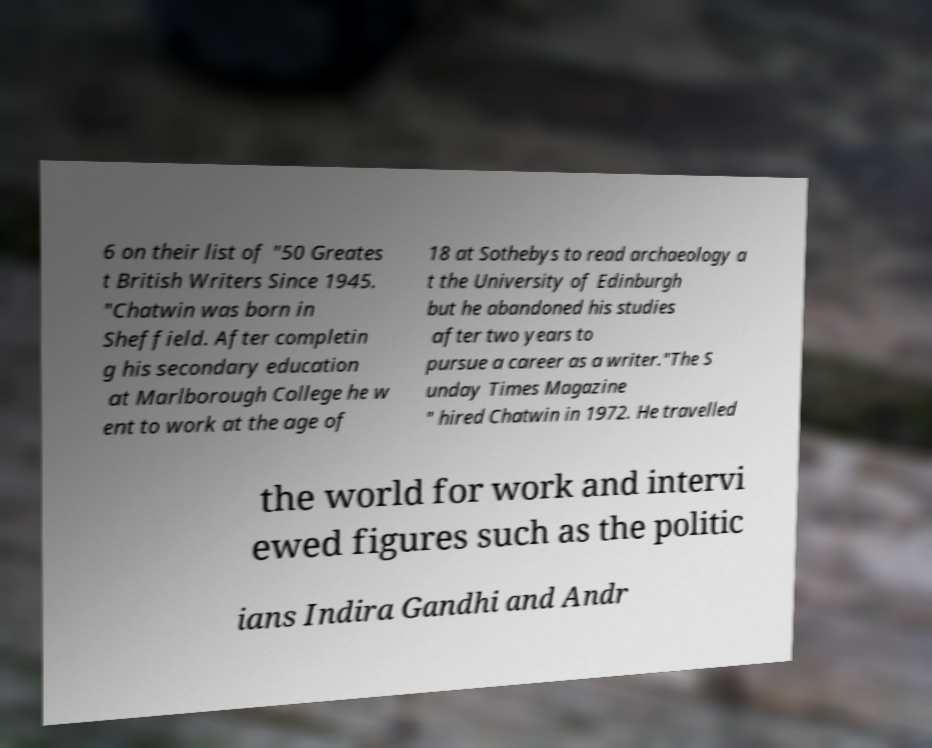For documentation purposes, I need the text within this image transcribed. Could you provide that? 6 on their list of "50 Greates t British Writers Since 1945. "Chatwin was born in Sheffield. After completin g his secondary education at Marlborough College he w ent to work at the age of 18 at Sothebys to read archaeology a t the University of Edinburgh but he abandoned his studies after two years to pursue a career as a writer."The S unday Times Magazine " hired Chatwin in 1972. He travelled the world for work and intervi ewed figures such as the politic ians Indira Gandhi and Andr 